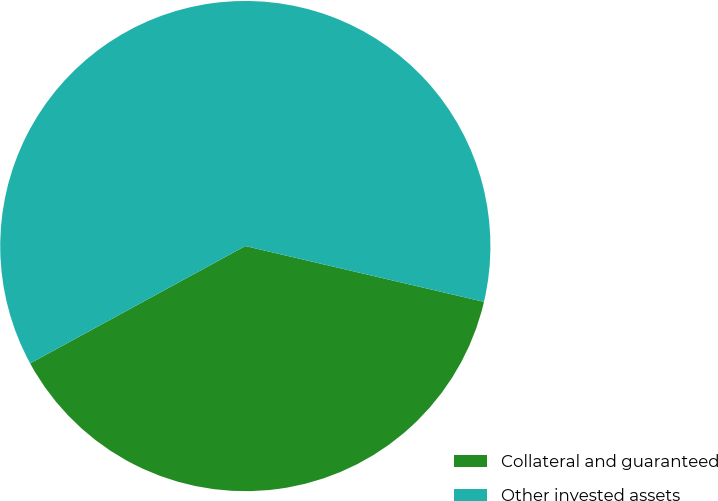<chart> <loc_0><loc_0><loc_500><loc_500><pie_chart><fcel>Collateral and guaranteed<fcel>Other invested assets<nl><fcel>38.4%<fcel>61.6%<nl></chart> 